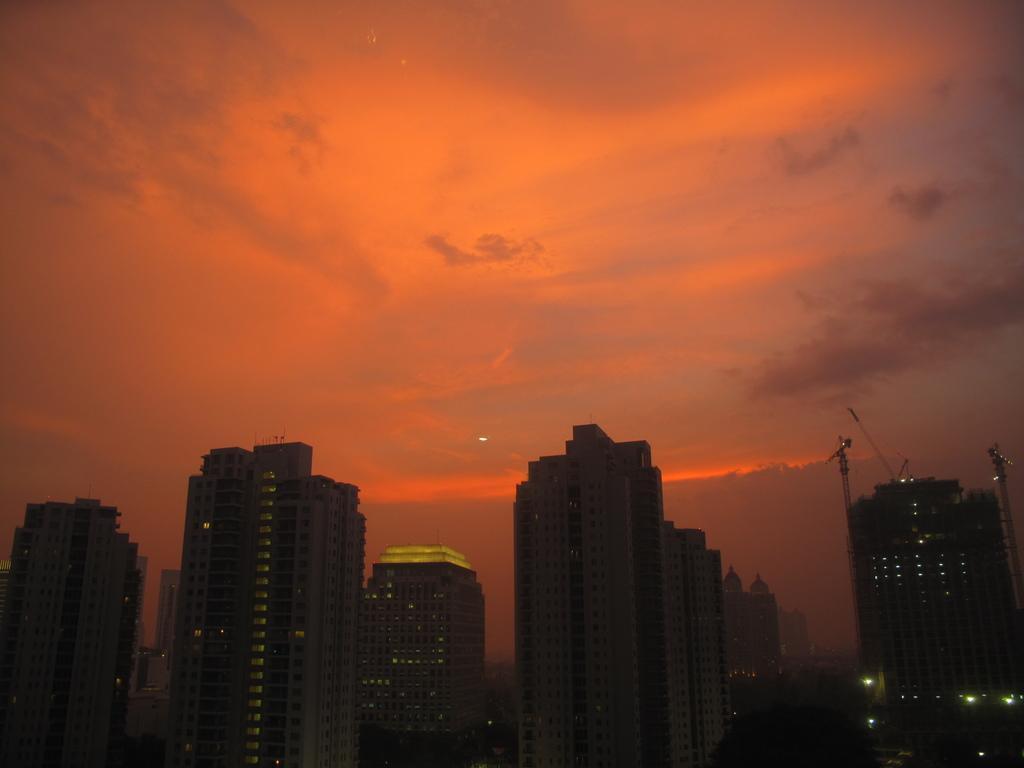Please provide a concise description of this image. In this picture we can see buildings, lights, some objects and in the background we can see the sky with clouds. 